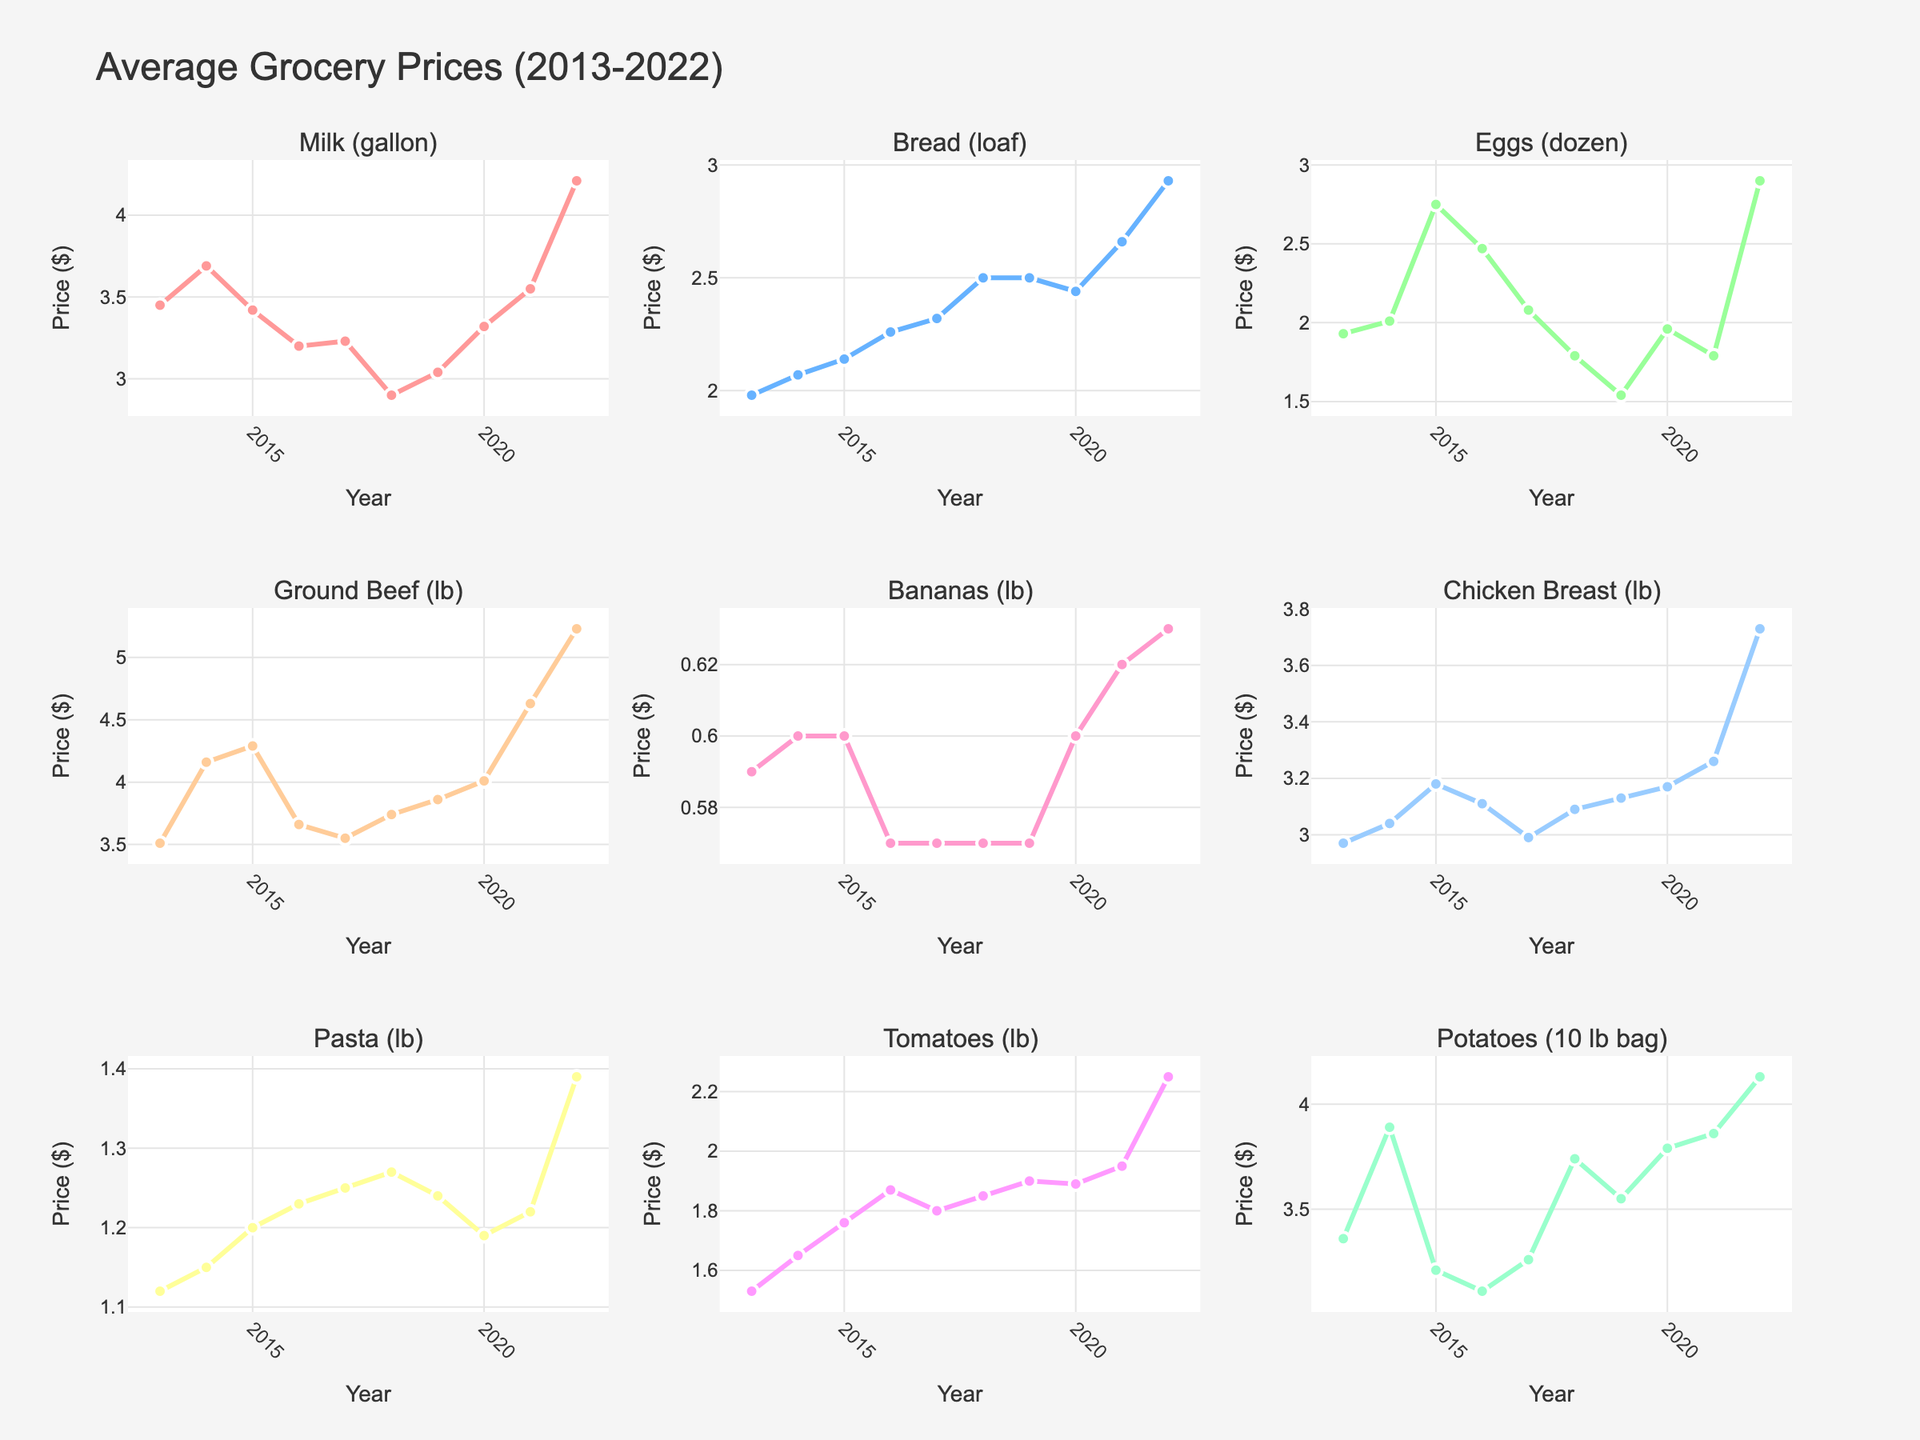What was the trend in the price of eggs over the decade? To determine the trend, observe the line for Eggs (dozen) in the figure for the years 2013 to 2022. Notice how the price fluctuates over time and identify whether it generally increased or decreased.
Answer: The price generally decreased, then increased sharply in 2022 Which year had the highest price for ground beef? Look at the Ground Beef (lb) subplot and identify the peak in the line. The highest point corresponds to the year with the highest price.
Answer: 2022 Did the price of chicken breast increase or decrease from 2013 to 2022? Compare the Chicken Breast (lb) price at the endpoints of the time range. Look at the value in 2013 and then compare it to 2022.
Answer: Increased In which year did the price of milk drop to its lowest? Identify the lowest point on the Milk (gallon) line chart and determine its corresponding year.
Answer: 2018 On average, which item had the highest increase in price from 2013 to 2022? For each item, calculate the price difference between 2013 and 2022 (ending price - starting price). The item with the highest value represents the greatest increase. Ground Beef: 5.23-3.51=1.72, Milk: 4.21-3.45=0.76, Bread: 2.93-1.98=0.95, Eggs: 2.90-1.93=0.97, Bananas: 0.63-0.59=0.04, Chicken Breast: 3.73-2.97=0.76, Pasta: 1.39-1.12=0.27, Tomatoes: 2.25-1.53=0.72, Potatoes: 4.13-3.36=0.77. Ground Beef had the highest increase.
Answer: Ground Beef Were there any items whose price remained relatively stable throughout the decade? Examine each item’s plot to see if the line is relatively flat. Investigate for minimal fluctuations each year to find a stable price trend.
Answer: Bananas In the years 2018 and 2019, how did the price of bread compare? Identify the price points for bread in 2018 and 2019 from the Bread (loaf) chart and compare the two values.
Answer: Same Which item showed the most significant price drop from 2021 to 2022? Calculate the price difference between 2021 and 2022 for all items and identify the most considerable decrease. Ground Beef: 5.23-4.63=0.60, Milk: 4.21-3.55=0.66, Bread: 2.93-2.66=0.27, Eggs: 2.90-1.79=1.11, Bananas: 0.63-0.62=0.01, Chicken Breast: 3.73-3.26=0.47, Pasta: 1.39-1.22=0.17, Tomatoes: 2.25-1.95=0.30, Potatoes: 4.13-3.86=0.27. Eggs had the most significant drop.
Answer: Eggs How did the price of pasta change from 2020 to 2021? Observe the Pasta (lb) data for the years 2020 and 2021, comparing the values to determine the change.
Answer: Increased What was the price difference of potatoes between the year with the highest price and the year with the lowest price? Identify the highest and lowest points in the Potatoes (10 lb bag) chart, then subtract the lower value from the higher value to find the difference. Highest price in 2022: 4.13, Lowest price in 2016: 3.11, Difference: 4.13 - 3.11 = 1.02
Answer: 1.02 